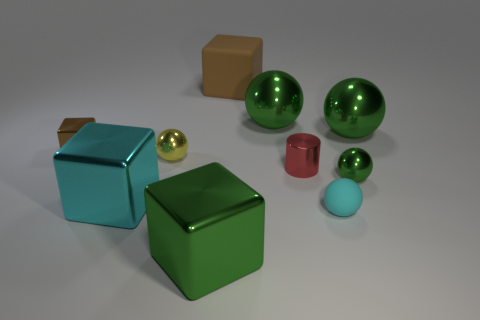Which objects in the image seem to have a shiny surface? The three green spheres and the two metallic cubes have shiny surfaces that reflect light, indicating a polished finish. 